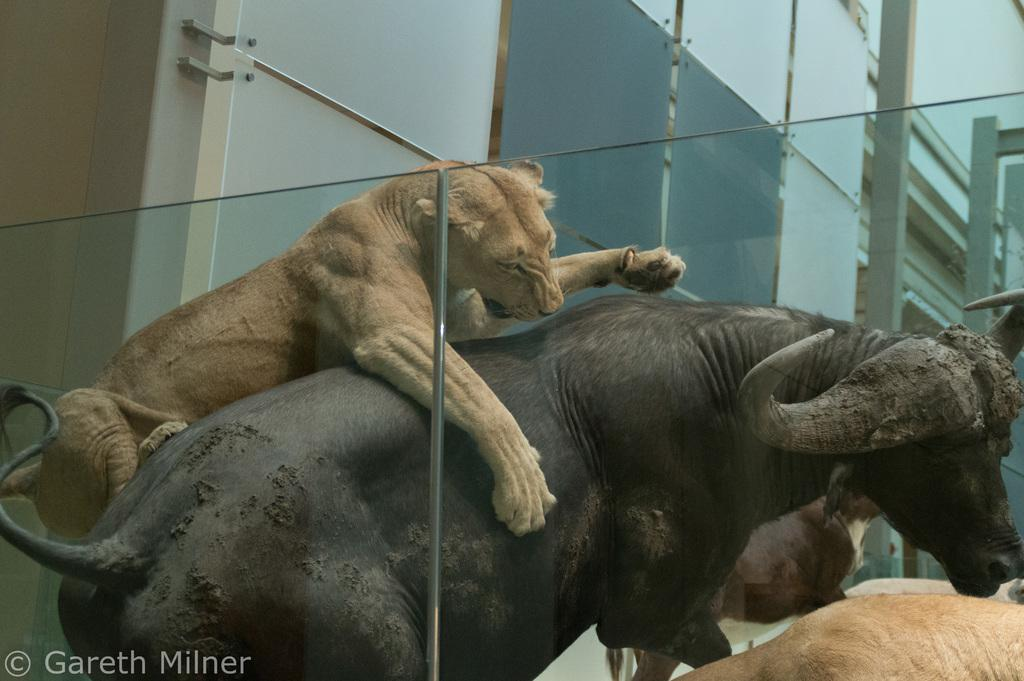What types of living organisms can be seen in the image? There are animals in the image. What structure is located in the middle of the image? There is a building in the middle of the image. What type of hammer can be seen in the image? There is no hammer present in the image. What type of school is depicted in the image? There is no school depicted in the image; it features animals and a building. 